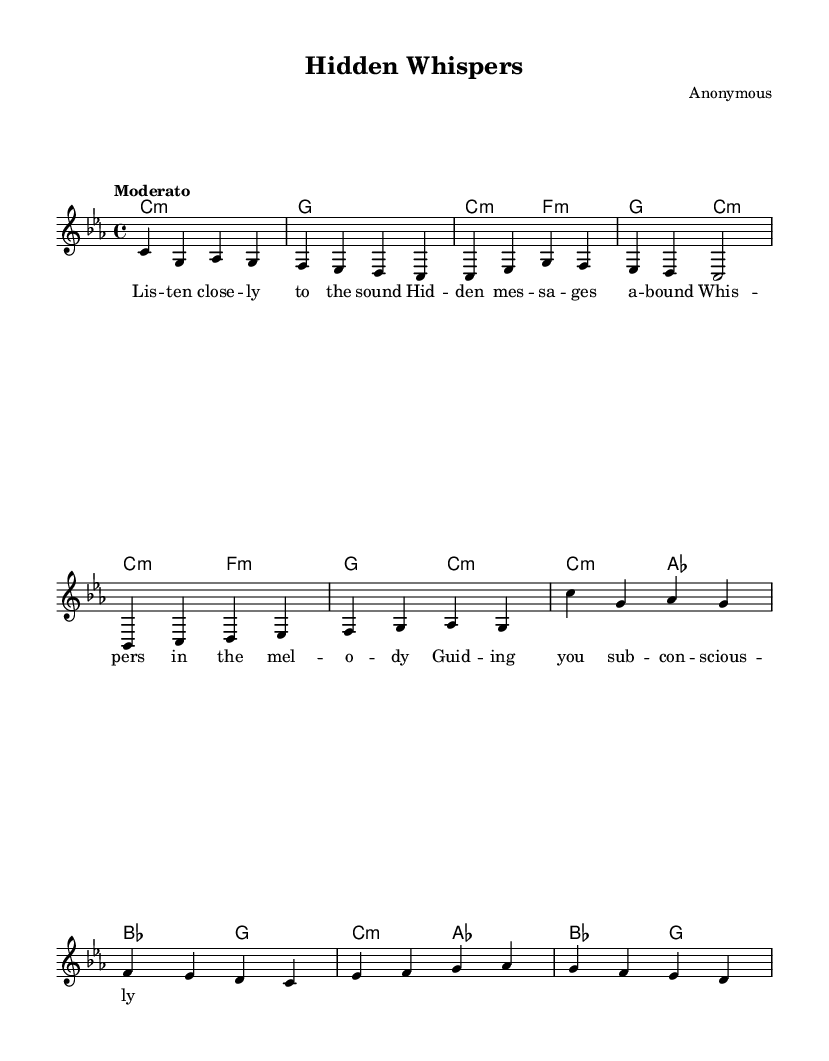What is the key signature of this music? The key signature is C minor, which contains three flats (B♭, E♭, and A♭). It can be identified by looking for the number of flats indicated at the beginning of the sheet music.
Answer: C minor What is the time signature of this music? The time signature is 4/4, which means there are four beats in each measure and the quarter note gets one beat. This can be observed in the time signature indicated at the beginning of the sheet music.
Answer: 4/4 What is the tempo marking for this piece? The tempo is marked as "Moderato," suggesting a moderate speed. This marking indicates how fast or slow the piece should be played and is generally found above the piano staff at the beginning of the score.
Answer: Moderato How many measures are in the melody section? There are eight measures in the melody section, which can be counted by looking at the vertical lines dividing the notes into groups in the sheet music.
Answer: Eight What is the first lyric text mentioned in the song? The first lyric text is "Lis -- ten close -- ly to the sound." This can be determined by examining the lyrics aligned with the melody notes in the sheet music, starting from the top.
Answer: Lis -- ten close -- ly to the sound What chord follows the introductory melody? The chord following the introductory melody is G major. This is found by looking at the chord symbols above the staff, specifically after the C minor chord in the introductory section of the piece.
Answer: G How does the chorus differ from the verse in terms of harmony? The chorus features a shift to the chords C minor and A♭ major, while the verse uses C minor and F minor primarily. This can be analyzed by examining the chords indicated above the melody that change between the sections of the song.
Answer: C minor and A♭ major 